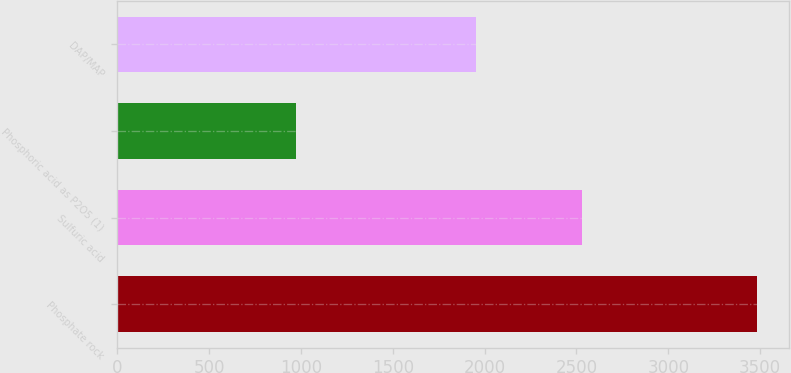Convert chart to OTSL. <chart><loc_0><loc_0><loc_500><loc_500><bar_chart><fcel>Phosphate rock<fcel>Sulfuric acid<fcel>Phosphoric acid as P2O5 (1)<fcel>DAP/MAP<nl><fcel>3483<fcel>2530<fcel>975<fcel>1952<nl></chart> 